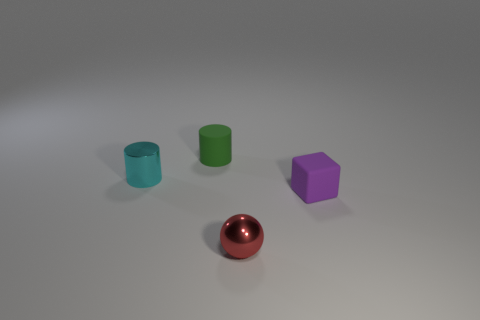Do the red metallic thing and the tiny object that is behind the cyan cylinder have the same shape?
Offer a terse response. No. How many purple rubber objects are the same size as the matte cylinder?
Your answer should be very brief. 1. Do the small shiny object in front of the small metal cylinder and the small rubber object that is left of the tiny purple thing have the same shape?
Offer a terse response. No. There is a small matte object to the right of the rubber object behind the cyan metallic cylinder; what color is it?
Make the answer very short. Purple. There is another tiny thing that is the same shape as the cyan thing; what color is it?
Keep it short and to the point. Green. Is there anything else that is made of the same material as the small red thing?
Ensure brevity in your answer.  Yes. There is a cyan object that is the same shape as the tiny green rubber thing; what size is it?
Make the answer very short. Small. There is a small red object that is left of the tiny purple block; what is it made of?
Provide a succinct answer. Metal. Are there fewer purple objects that are on the left side of the metallic cylinder than tiny yellow metal balls?
Provide a succinct answer. No. There is a shiny object on the right side of the small cylinder that is in front of the tiny green cylinder; what is its shape?
Keep it short and to the point. Sphere. 